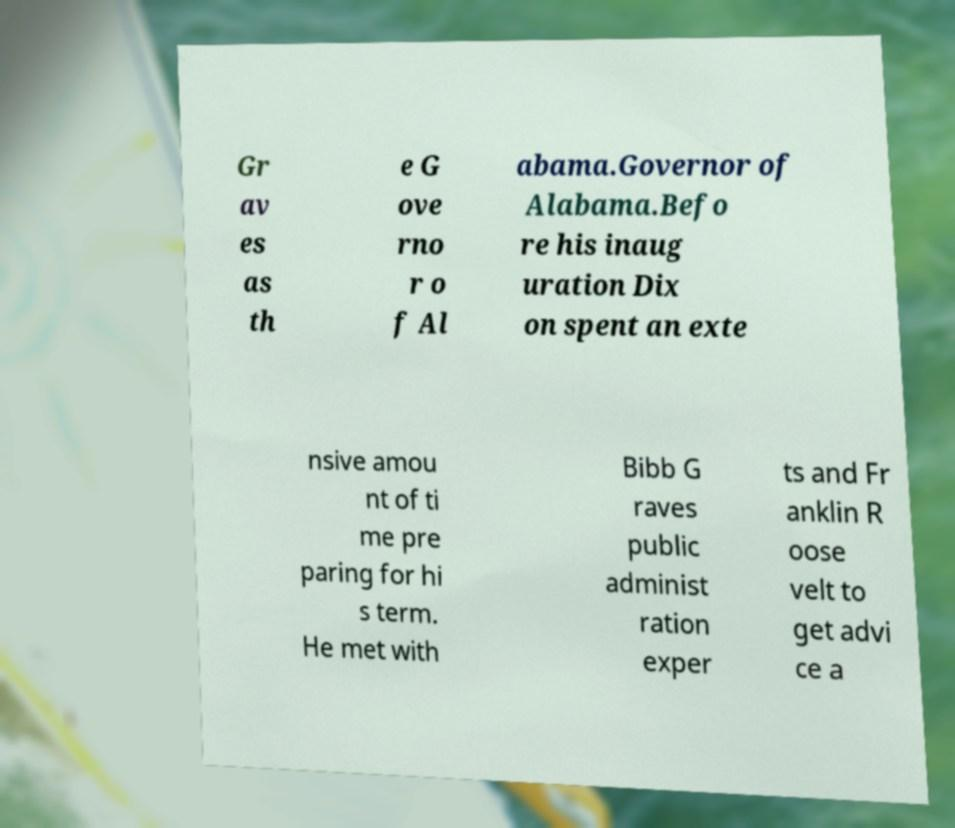Can you read and provide the text displayed in the image?This photo seems to have some interesting text. Can you extract and type it out for me? Gr av es as th e G ove rno r o f Al abama.Governor of Alabama.Befo re his inaug uration Dix on spent an exte nsive amou nt of ti me pre paring for hi s term. He met with Bibb G raves public administ ration exper ts and Fr anklin R oose velt to get advi ce a 